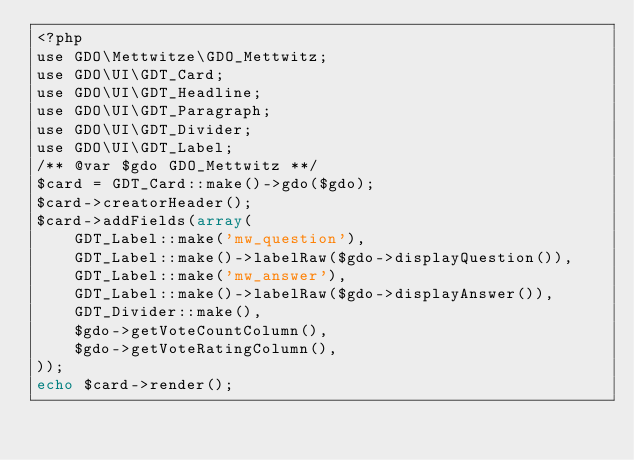<code> <loc_0><loc_0><loc_500><loc_500><_PHP_><?php
use GDO\Mettwitze\GDO_Mettwitz;
use GDO\UI\GDT_Card;
use GDO\UI\GDT_Headline;
use GDO\UI\GDT_Paragraph;
use GDO\UI\GDT_Divider;
use GDO\UI\GDT_Label;
/** @var $gdo GDO_Mettwitz **/
$card = GDT_Card::make()->gdo($gdo);
$card->creatorHeader();
$card->addFields(array(
    GDT_Label::make('mw_question'),
    GDT_Label::make()->labelRaw($gdo->displayQuestion()),
    GDT_Label::make('mw_answer'),
    GDT_Label::make()->labelRaw($gdo->displayAnswer()),
	GDT_Divider::make(),
	$gdo->getVoteCountColumn(),
	$gdo->getVoteRatingColumn(),
));
echo $card->render();
</code> 